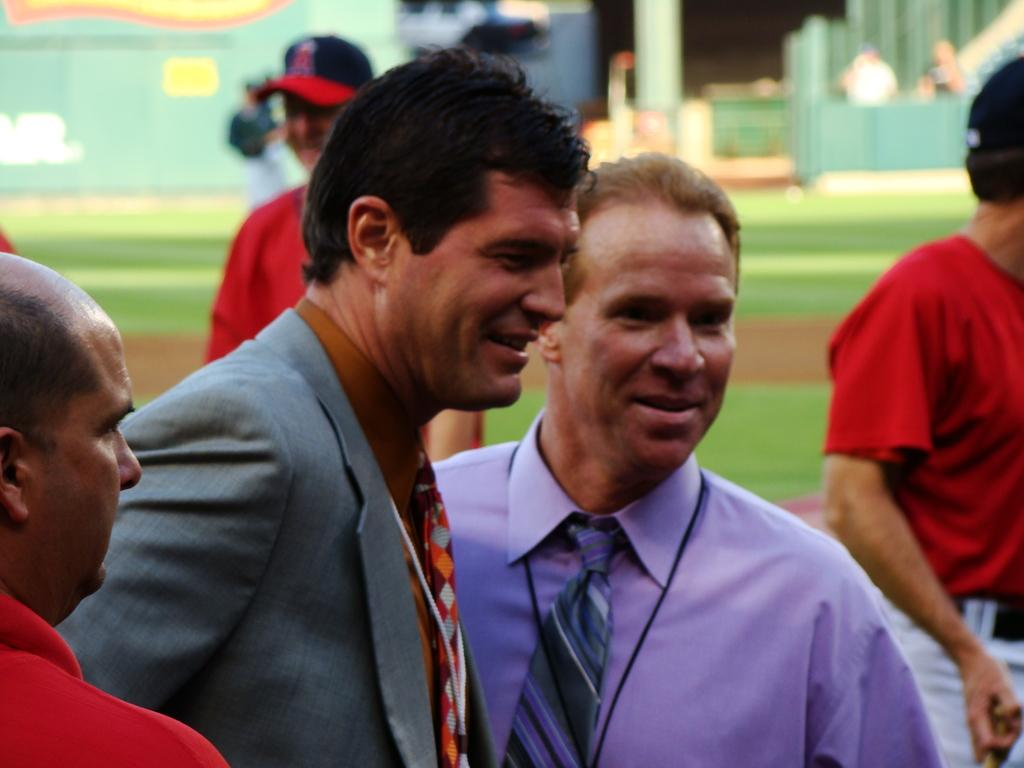How many people are in the image? There are persons in the image, but the exact number is not specified. What are the persons wearing? The persons are wearing clothes. Can you describe the background of the image? The background of the image is blurred. What type of winter clothing can be seen on the persons in the image? There is no mention of winter clothing or any specific season in the image, so it cannot be determined from the facts. 